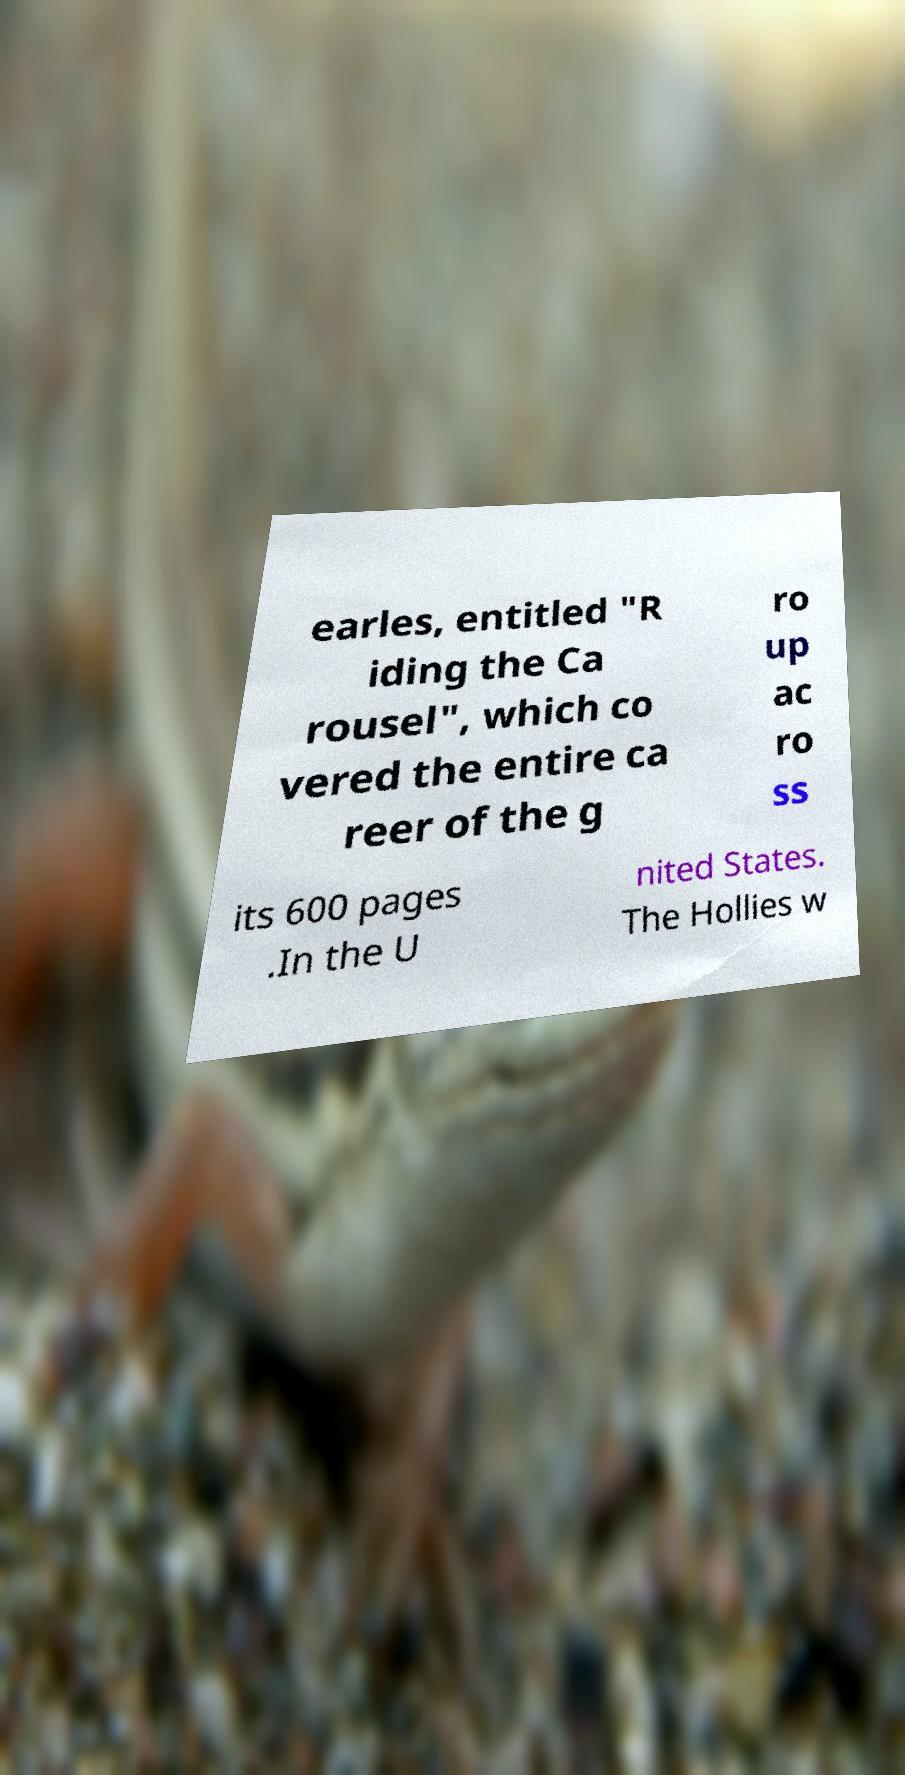I need the written content from this picture converted into text. Can you do that? earles, entitled "R iding the Ca rousel", which co vered the entire ca reer of the g ro up ac ro ss its 600 pages .In the U nited States. The Hollies w 